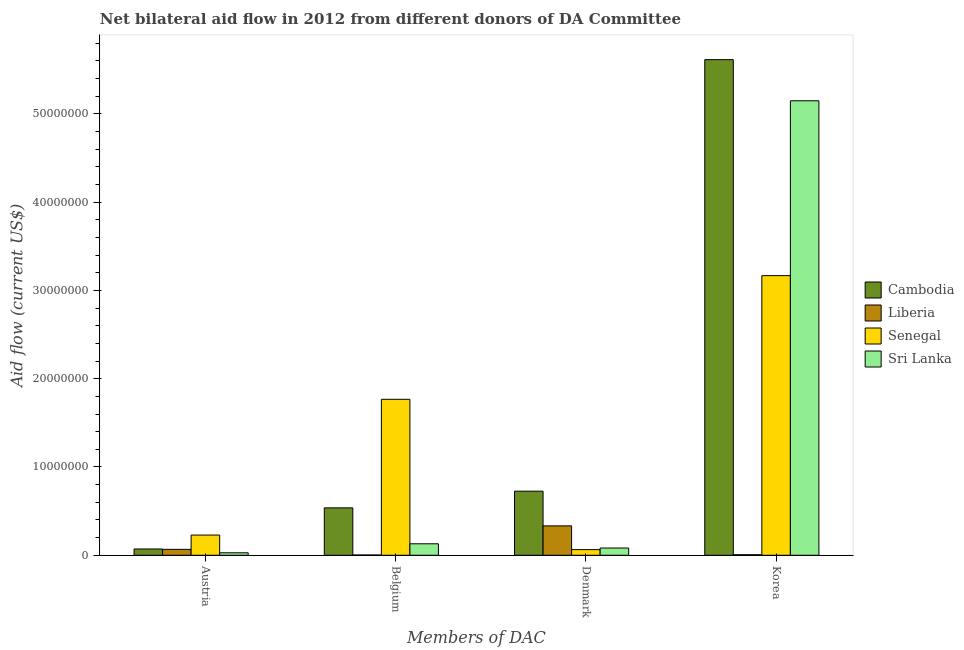How many groups of bars are there?
Make the answer very short. 4. How many bars are there on the 2nd tick from the left?
Provide a short and direct response. 4. How many bars are there on the 2nd tick from the right?
Your answer should be compact. 4. What is the label of the 2nd group of bars from the left?
Make the answer very short. Belgium. What is the amount of aid given by denmark in Sri Lanka?
Offer a terse response. 8.20e+05. Across all countries, what is the maximum amount of aid given by austria?
Make the answer very short. 2.29e+06. Across all countries, what is the minimum amount of aid given by denmark?
Give a very brief answer. 6.40e+05. In which country was the amount of aid given by belgium maximum?
Make the answer very short. Senegal. In which country was the amount of aid given by belgium minimum?
Offer a terse response. Liberia. What is the total amount of aid given by belgium in the graph?
Offer a very short reply. 2.44e+07. What is the difference between the amount of aid given by belgium in Cambodia and that in Liberia?
Offer a terse response. 5.34e+06. What is the difference between the amount of aid given by belgium in Liberia and the amount of aid given by denmark in Senegal?
Give a very brief answer. -6.10e+05. What is the average amount of aid given by denmark per country?
Give a very brief answer. 3.01e+06. What is the difference between the amount of aid given by denmark and amount of aid given by belgium in Liberia?
Your answer should be very brief. 3.30e+06. In how many countries, is the amount of aid given by belgium greater than 40000000 US$?
Make the answer very short. 0. What is the ratio of the amount of aid given by korea in Liberia to that in Sri Lanka?
Offer a terse response. 0. What is the difference between the highest and the second highest amount of aid given by denmark?
Offer a terse response. 3.93e+06. What is the difference between the highest and the lowest amount of aid given by austria?
Give a very brief answer. 2.01e+06. In how many countries, is the amount of aid given by belgium greater than the average amount of aid given by belgium taken over all countries?
Offer a terse response. 1. What does the 2nd bar from the left in Austria represents?
Make the answer very short. Liberia. What does the 4th bar from the right in Korea represents?
Ensure brevity in your answer.  Cambodia. Is it the case that in every country, the sum of the amount of aid given by austria and amount of aid given by belgium is greater than the amount of aid given by denmark?
Make the answer very short. No. How many countries are there in the graph?
Provide a short and direct response. 4. Does the graph contain any zero values?
Provide a short and direct response. No. Where does the legend appear in the graph?
Provide a succinct answer. Center right. How many legend labels are there?
Your answer should be very brief. 4. What is the title of the graph?
Your answer should be compact. Net bilateral aid flow in 2012 from different donors of DA Committee. What is the label or title of the X-axis?
Provide a succinct answer. Members of DAC. What is the Aid flow (current US$) of Cambodia in Austria?
Your response must be concise. 7.10e+05. What is the Aid flow (current US$) of Liberia in Austria?
Your response must be concise. 6.70e+05. What is the Aid flow (current US$) of Senegal in Austria?
Offer a very short reply. 2.29e+06. What is the Aid flow (current US$) in Cambodia in Belgium?
Keep it short and to the point. 5.37e+06. What is the Aid flow (current US$) of Liberia in Belgium?
Your response must be concise. 3.00e+04. What is the Aid flow (current US$) in Senegal in Belgium?
Give a very brief answer. 1.77e+07. What is the Aid flow (current US$) of Sri Lanka in Belgium?
Your answer should be compact. 1.30e+06. What is the Aid flow (current US$) in Cambodia in Denmark?
Your response must be concise. 7.26e+06. What is the Aid flow (current US$) in Liberia in Denmark?
Make the answer very short. 3.33e+06. What is the Aid flow (current US$) of Senegal in Denmark?
Make the answer very short. 6.40e+05. What is the Aid flow (current US$) in Sri Lanka in Denmark?
Provide a succinct answer. 8.20e+05. What is the Aid flow (current US$) in Cambodia in Korea?
Make the answer very short. 5.62e+07. What is the Aid flow (current US$) of Senegal in Korea?
Make the answer very short. 3.17e+07. What is the Aid flow (current US$) in Sri Lanka in Korea?
Give a very brief answer. 5.15e+07. Across all Members of DAC, what is the maximum Aid flow (current US$) of Cambodia?
Provide a short and direct response. 5.62e+07. Across all Members of DAC, what is the maximum Aid flow (current US$) in Liberia?
Offer a very short reply. 3.33e+06. Across all Members of DAC, what is the maximum Aid flow (current US$) of Senegal?
Offer a terse response. 3.17e+07. Across all Members of DAC, what is the maximum Aid flow (current US$) of Sri Lanka?
Offer a terse response. 5.15e+07. Across all Members of DAC, what is the minimum Aid flow (current US$) in Cambodia?
Your response must be concise. 7.10e+05. Across all Members of DAC, what is the minimum Aid flow (current US$) of Liberia?
Offer a very short reply. 3.00e+04. Across all Members of DAC, what is the minimum Aid flow (current US$) in Senegal?
Ensure brevity in your answer.  6.40e+05. Across all Members of DAC, what is the minimum Aid flow (current US$) in Sri Lanka?
Keep it short and to the point. 2.80e+05. What is the total Aid flow (current US$) of Cambodia in the graph?
Offer a very short reply. 6.95e+07. What is the total Aid flow (current US$) of Liberia in the graph?
Offer a terse response. 4.09e+06. What is the total Aid flow (current US$) of Senegal in the graph?
Ensure brevity in your answer.  5.23e+07. What is the total Aid flow (current US$) in Sri Lanka in the graph?
Your answer should be compact. 5.39e+07. What is the difference between the Aid flow (current US$) of Cambodia in Austria and that in Belgium?
Your answer should be compact. -4.66e+06. What is the difference between the Aid flow (current US$) of Liberia in Austria and that in Belgium?
Give a very brief answer. 6.40e+05. What is the difference between the Aid flow (current US$) in Senegal in Austria and that in Belgium?
Your answer should be compact. -1.54e+07. What is the difference between the Aid flow (current US$) of Sri Lanka in Austria and that in Belgium?
Offer a very short reply. -1.02e+06. What is the difference between the Aid flow (current US$) of Cambodia in Austria and that in Denmark?
Your answer should be compact. -6.55e+06. What is the difference between the Aid flow (current US$) of Liberia in Austria and that in Denmark?
Provide a short and direct response. -2.66e+06. What is the difference between the Aid flow (current US$) in Senegal in Austria and that in Denmark?
Your answer should be compact. 1.65e+06. What is the difference between the Aid flow (current US$) of Sri Lanka in Austria and that in Denmark?
Provide a succinct answer. -5.40e+05. What is the difference between the Aid flow (current US$) in Cambodia in Austria and that in Korea?
Your answer should be compact. -5.54e+07. What is the difference between the Aid flow (current US$) of Liberia in Austria and that in Korea?
Your answer should be compact. 6.10e+05. What is the difference between the Aid flow (current US$) of Senegal in Austria and that in Korea?
Make the answer very short. -2.94e+07. What is the difference between the Aid flow (current US$) in Sri Lanka in Austria and that in Korea?
Give a very brief answer. -5.12e+07. What is the difference between the Aid flow (current US$) in Cambodia in Belgium and that in Denmark?
Your response must be concise. -1.89e+06. What is the difference between the Aid flow (current US$) in Liberia in Belgium and that in Denmark?
Provide a short and direct response. -3.30e+06. What is the difference between the Aid flow (current US$) of Senegal in Belgium and that in Denmark?
Your answer should be very brief. 1.70e+07. What is the difference between the Aid flow (current US$) of Sri Lanka in Belgium and that in Denmark?
Provide a short and direct response. 4.80e+05. What is the difference between the Aid flow (current US$) of Cambodia in Belgium and that in Korea?
Provide a succinct answer. -5.08e+07. What is the difference between the Aid flow (current US$) in Liberia in Belgium and that in Korea?
Provide a short and direct response. -3.00e+04. What is the difference between the Aid flow (current US$) in Senegal in Belgium and that in Korea?
Make the answer very short. -1.40e+07. What is the difference between the Aid flow (current US$) of Sri Lanka in Belgium and that in Korea?
Ensure brevity in your answer.  -5.02e+07. What is the difference between the Aid flow (current US$) in Cambodia in Denmark and that in Korea?
Ensure brevity in your answer.  -4.89e+07. What is the difference between the Aid flow (current US$) in Liberia in Denmark and that in Korea?
Provide a succinct answer. 3.27e+06. What is the difference between the Aid flow (current US$) of Senegal in Denmark and that in Korea?
Offer a terse response. -3.10e+07. What is the difference between the Aid flow (current US$) of Sri Lanka in Denmark and that in Korea?
Make the answer very short. -5.07e+07. What is the difference between the Aid flow (current US$) in Cambodia in Austria and the Aid flow (current US$) in Liberia in Belgium?
Provide a short and direct response. 6.80e+05. What is the difference between the Aid flow (current US$) of Cambodia in Austria and the Aid flow (current US$) of Senegal in Belgium?
Provide a succinct answer. -1.70e+07. What is the difference between the Aid flow (current US$) in Cambodia in Austria and the Aid flow (current US$) in Sri Lanka in Belgium?
Ensure brevity in your answer.  -5.90e+05. What is the difference between the Aid flow (current US$) in Liberia in Austria and the Aid flow (current US$) in Senegal in Belgium?
Ensure brevity in your answer.  -1.70e+07. What is the difference between the Aid flow (current US$) of Liberia in Austria and the Aid flow (current US$) of Sri Lanka in Belgium?
Your response must be concise. -6.30e+05. What is the difference between the Aid flow (current US$) in Senegal in Austria and the Aid flow (current US$) in Sri Lanka in Belgium?
Offer a terse response. 9.90e+05. What is the difference between the Aid flow (current US$) in Cambodia in Austria and the Aid flow (current US$) in Liberia in Denmark?
Provide a succinct answer. -2.62e+06. What is the difference between the Aid flow (current US$) of Cambodia in Austria and the Aid flow (current US$) of Senegal in Denmark?
Your answer should be very brief. 7.00e+04. What is the difference between the Aid flow (current US$) of Cambodia in Austria and the Aid flow (current US$) of Sri Lanka in Denmark?
Your answer should be very brief. -1.10e+05. What is the difference between the Aid flow (current US$) in Liberia in Austria and the Aid flow (current US$) in Senegal in Denmark?
Provide a succinct answer. 3.00e+04. What is the difference between the Aid flow (current US$) in Liberia in Austria and the Aid flow (current US$) in Sri Lanka in Denmark?
Keep it short and to the point. -1.50e+05. What is the difference between the Aid flow (current US$) of Senegal in Austria and the Aid flow (current US$) of Sri Lanka in Denmark?
Provide a succinct answer. 1.47e+06. What is the difference between the Aid flow (current US$) of Cambodia in Austria and the Aid flow (current US$) of Liberia in Korea?
Provide a short and direct response. 6.50e+05. What is the difference between the Aid flow (current US$) in Cambodia in Austria and the Aid flow (current US$) in Senegal in Korea?
Ensure brevity in your answer.  -3.10e+07. What is the difference between the Aid flow (current US$) of Cambodia in Austria and the Aid flow (current US$) of Sri Lanka in Korea?
Your answer should be very brief. -5.08e+07. What is the difference between the Aid flow (current US$) in Liberia in Austria and the Aid flow (current US$) in Senegal in Korea?
Provide a short and direct response. -3.10e+07. What is the difference between the Aid flow (current US$) of Liberia in Austria and the Aid flow (current US$) of Sri Lanka in Korea?
Provide a short and direct response. -5.08e+07. What is the difference between the Aid flow (current US$) in Senegal in Austria and the Aid flow (current US$) in Sri Lanka in Korea?
Offer a very short reply. -4.92e+07. What is the difference between the Aid flow (current US$) of Cambodia in Belgium and the Aid flow (current US$) of Liberia in Denmark?
Provide a succinct answer. 2.04e+06. What is the difference between the Aid flow (current US$) of Cambodia in Belgium and the Aid flow (current US$) of Senegal in Denmark?
Your answer should be very brief. 4.73e+06. What is the difference between the Aid flow (current US$) in Cambodia in Belgium and the Aid flow (current US$) in Sri Lanka in Denmark?
Make the answer very short. 4.55e+06. What is the difference between the Aid flow (current US$) of Liberia in Belgium and the Aid flow (current US$) of Senegal in Denmark?
Keep it short and to the point. -6.10e+05. What is the difference between the Aid flow (current US$) in Liberia in Belgium and the Aid flow (current US$) in Sri Lanka in Denmark?
Your answer should be compact. -7.90e+05. What is the difference between the Aid flow (current US$) of Senegal in Belgium and the Aid flow (current US$) of Sri Lanka in Denmark?
Offer a terse response. 1.68e+07. What is the difference between the Aid flow (current US$) in Cambodia in Belgium and the Aid flow (current US$) in Liberia in Korea?
Offer a very short reply. 5.31e+06. What is the difference between the Aid flow (current US$) of Cambodia in Belgium and the Aid flow (current US$) of Senegal in Korea?
Provide a succinct answer. -2.63e+07. What is the difference between the Aid flow (current US$) in Cambodia in Belgium and the Aid flow (current US$) in Sri Lanka in Korea?
Provide a succinct answer. -4.61e+07. What is the difference between the Aid flow (current US$) in Liberia in Belgium and the Aid flow (current US$) in Senegal in Korea?
Offer a terse response. -3.16e+07. What is the difference between the Aid flow (current US$) in Liberia in Belgium and the Aid flow (current US$) in Sri Lanka in Korea?
Provide a succinct answer. -5.15e+07. What is the difference between the Aid flow (current US$) in Senegal in Belgium and the Aid flow (current US$) in Sri Lanka in Korea?
Provide a short and direct response. -3.38e+07. What is the difference between the Aid flow (current US$) of Cambodia in Denmark and the Aid flow (current US$) of Liberia in Korea?
Make the answer very short. 7.20e+06. What is the difference between the Aid flow (current US$) of Cambodia in Denmark and the Aid flow (current US$) of Senegal in Korea?
Offer a very short reply. -2.44e+07. What is the difference between the Aid flow (current US$) in Cambodia in Denmark and the Aid flow (current US$) in Sri Lanka in Korea?
Make the answer very short. -4.42e+07. What is the difference between the Aid flow (current US$) of Liberia in Denmark and the Aid flow (current US$) of Senegal in Korea?
Ensure brevity in your answer.  -2.84e+07. What is the difference between the Aid flow (current US$) of Liberia in Denmark and the Aid flow (current US$) of Sri Lanka in Korea?
Offer a very short reply. -4.82e+07. What is the difference between the Aid flow (current US$) of Senegal in Denmark and the Aid flow (current US$) of Sri Lanka in Korea?
Ensure brevity in your answer.  -5.08e+07. What is the average Aid flow (current US$) of Cambodia per Members of DAC?
Provide a short and direct response. 1.74e+07. What is the average Aid flow (current US$) in Liberia per Members of DAC?
Offer a very short reply. 1.02e+06. What is the average Aid flow (current US$) in Senegal per Members of DAC?
Your response must be concise. 1.31e+07. What is the average Aid flow (current US$) of Sri Lanka per Members of DAC?
Make the answer very short. 1.35e+07. What is the difference between the Aid flow (current US$) in Cambodia and Aid flow (current US$) in Senegal in Austria?
Your answer should be compact. -1.58e+06. What is the difference between the Aid flow (current US$) of Liberia and Aid flow (current US$) of Senegal in Austria?
Give a very brief answer. -1.62e+06. What is the difference between the Aid flow (current US$) of Liberia and Aid flow (current US$) of Sri Lanka in Austria?
Give a very brief answer. 3.90e+05. What is the difference between the Aid flow (current US$) of Senegal and Aid flow (current US$) of Sri Lanka in Austria?
Your response must be concise. 2.01e+06. What is the difference between the Aid flow (current US$) of Cambodia and Aid flow (current US$) of Liberia in Belgium?
Give a very brief answer. 5.34e+06. What is the difference between the Aid flow (current US$) of Cambodia and Aid flow (current US$) of Senegal in Belgium?
Make the answer very short. -1.23e+07. What is the difference between the Aid flow (current US$) of Cambodia and Aid flow (current US$) of Sri Lanka in Belgium?
Ensure brevity in your answer.  4.07e+06. What is the difference between the Aid flow (current US$) of Liberia and Aid flow (current US$) of Senegal in Belgium?
Keep it short and to the point. -1.76e+07. What is the difference between the Aid flow (current US$) in Liberia and Aid flow (current US$) in Sri Lanka in Belgium?
Offer a very short reply. -1.27e+06. What is the difference between the Aid flow (current US$) of Senegal and Aid flow (current US$) of Sri Lanka in Belgium?
Give a very brief answer. 1.64e+07. What is the difference between the Aid flow (current US$) in Cambodia and Aid flow (current US$) in Liberia in Denmark?
Provide a short and direct response. 3.93e+06. What is the difference between the Aid flow (current US$) of Cambodia and Aid flow (current US$) of Senegal in Denmark?
Give a very brief answer. 6.62e+06. What is the difference between the Aid flow (current US$) of Cambodia and Aid flow (current US$) of Sri Lanka in Denmark?
Make the answer very short. 6.44e+06. What is the difference between the Aid flow (current US$) in Liberia and Aid flow (current US$) in Senegal in Denmark?
Provide a short and direct response. 2.69e+06. What is the difference between the Aid flow (current US$) of Liberia and Aid flow (current US$) of Sri Lanka in Denmark?
Your answer should be very brief. 2.51e+06. What is the difference between the Aid flow (current US$) in Senegal and Aid flow (current US$) in Sri Lanka in Denmark?
Make the answer very short. -1.80e+05. What is the difference between the Aid flow (current US$) in Cambodia and Aid flow (current US$) in Liberia in Korea?
Give a very brief answer. 5.61e+07. What is the difference between the Aid flow (current US$) of Cambodia and Aid flow (current US$) of Senegal in Korea?
Your response must be concise. 2.45e+07. What is the difference between the Aid flow (current US$) in Cambodia and Aid flow (current US$) in Sri Lanka in Korea?
Keep it short and to the point. 4.66e+06. What is the difference between the Aid flow (current US$) of Liberia and Aid flow (current US$) of Senegal in Korea?
Provide a short and direct response. -3.16e+07. What is the difference between the Aid flow (current US$) of Liberia and Aid flow (current US$) of Sri Lanka in Korea?
Ensure brevity in your answer.  -5.14e+07. What is the difference between the Aid flow (current US$) in Senegal and Aid flow (current US$) in Sri Lanka in Korea?
Ensure brevity in your answer.  -1.98e+07. What is the ratio of the Aid flow (current US$) of Cambodia in Austria to that in Belgium?
Your answer should be compact. 0.13. What is the ratio of the Aid flow (current US$) of Liberia in Austria to that in Belgium?
Your answer should be compact. 22.33. What is the ratio of the Aid flow (current US$) in Senegal in Austria to that in Belgium?
Your response must be concise. 0.13. What is the ratio of the Aid flow (current US$) of Sri Lanka in Austria to that in Belgium?
Provide a succinct answer. 0.22. What is the ratio of the Aid flow (current US$) of Cambodia in Austria to that in Denmark?
Provide a succinct answer. 0.1. What is the ratio of the Aid flow (current US$) in Liberia in Austria to that in Denmark?
Give a very brief answer. 0.2. What is the ratio of the Aid flow (current US$) in Senegal in Austria to that in Denmark?
Your response must be concise. 3.58. What is the ratio of the Aid flow (current US$) in Sri Lanka in Austria to that in Denmark?
Provide a succinct answer. 0.34. What is the ratio of the Aid flow (current US$) in Cambodia in Austria to that in Korea?
Offer a terse response. 0.01. What is the ratio of the Aid flow (current US$) in Liberia in Austria to that in Korea?
Your response must be concise. 11.17. What is the ratio of the Aid flow (current US$) of Senegal in Austria to that in Korea?
Ensure brevity in your answer.  0.07. What is the ratio of the Aid flow (current US$) in Sri Lanka in Austria to that in Korea?
Provide a succinct answer. 0.01. What is the ratio of the Aid flow (current US$) of Cambodia in Belgium to that in Denmark?
Ensure brevity in your answer.  0.74. What is the ratio of the Aid flow (current US$) of Liberia in Belgium to that in Denmark?
Offer a very short reply. 0.01. What is the ratio of the Aid flow (current US$) in Senegal in Belgium to that in Denmark?
Keep it short and to the point. 27.61. What is the ratio of the Aid flow (current US$) in Sri Lanka in Belgium to that in Denmark?
Your response must be concise. 1.59. What is the ratio of the Aid flow (current US$) of Cambodia in Belgium to that in Korea?
Provide a succinct answer. 0.1. What is the ratio of the Aid flow (current US$) in Liberia in Belgium to that in Korea?
Your response must be concise. 0.5. What is the ratio of the Aid flow (current US$) of Senegal in Belgium to that in Korea?
Your answer should be compact. 0.56. What is the ratio of the Aid flow (current US$) of Sri Lanka in Belgium to that in Korea?
Give a very brief answer. 0.03. What is the ratio of the Aid flow (current US$) in Cambodia in Denmark to that in Korea?
Offer a terse response. 0.13. What is the ratio of the Aid flow (current US$) in Liberia in Denmark to that in Korea?
Ensure brevity in your answer.  55.5. What is the ratio of the Aid flow (current US$) in Senegal in Denmark to that in Korea?
Your answer should be compact. 0.02. What is the ratio of the Aid flow (current US$) of Sri Lanka in Denmark to that in Korea?
Provide a short and direct response. 0.02. What is the difference between the highest and the second highest Aid flow (current US$) in Cambodia?
Ensure brevity in your answer.  4.89e+07. What is the difference between the highest and the second highest Aid flow (current US$) in Liberia?
Provide a succinct answer. 2.66e+06. What is the difference between the highest and the second highest Aid flow (current US$) in Senegal?
Ensure brevity in your answer.  1.40e+07. What is the difference between the highest and the second highest Aid flow (current US$) in Sri Lanka?
Give a very brief answer. 5.02e+07. What is the difference between the highest and the lowest Aid flow (current US$) in Cambodia?
Give a very brief answer. 5.54e+07. What is the difference between the highest and the lowest Aid flow (current US$) in Liberia?
Provide a succinct answer. 3.30e+06. What is the difference between the highest and the lowest Aid flow (current US$) in Senegal?
Make the answer very short. 3.10e+07. What is the difference between the highest and the lowest Aid flow (current US$) in Sri Lanka?
Ensure brevity in your answer.  5.12e+07. 